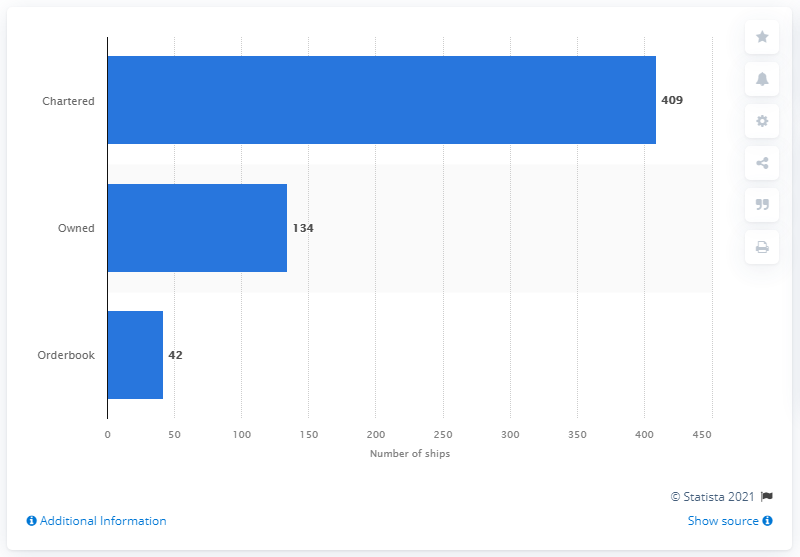Specify some key components in this picture. As of June 28, 2021, the CMA CGM Group had 42 vessels in its order book. The CMA CGM Group has charted a total of 409 ships. 